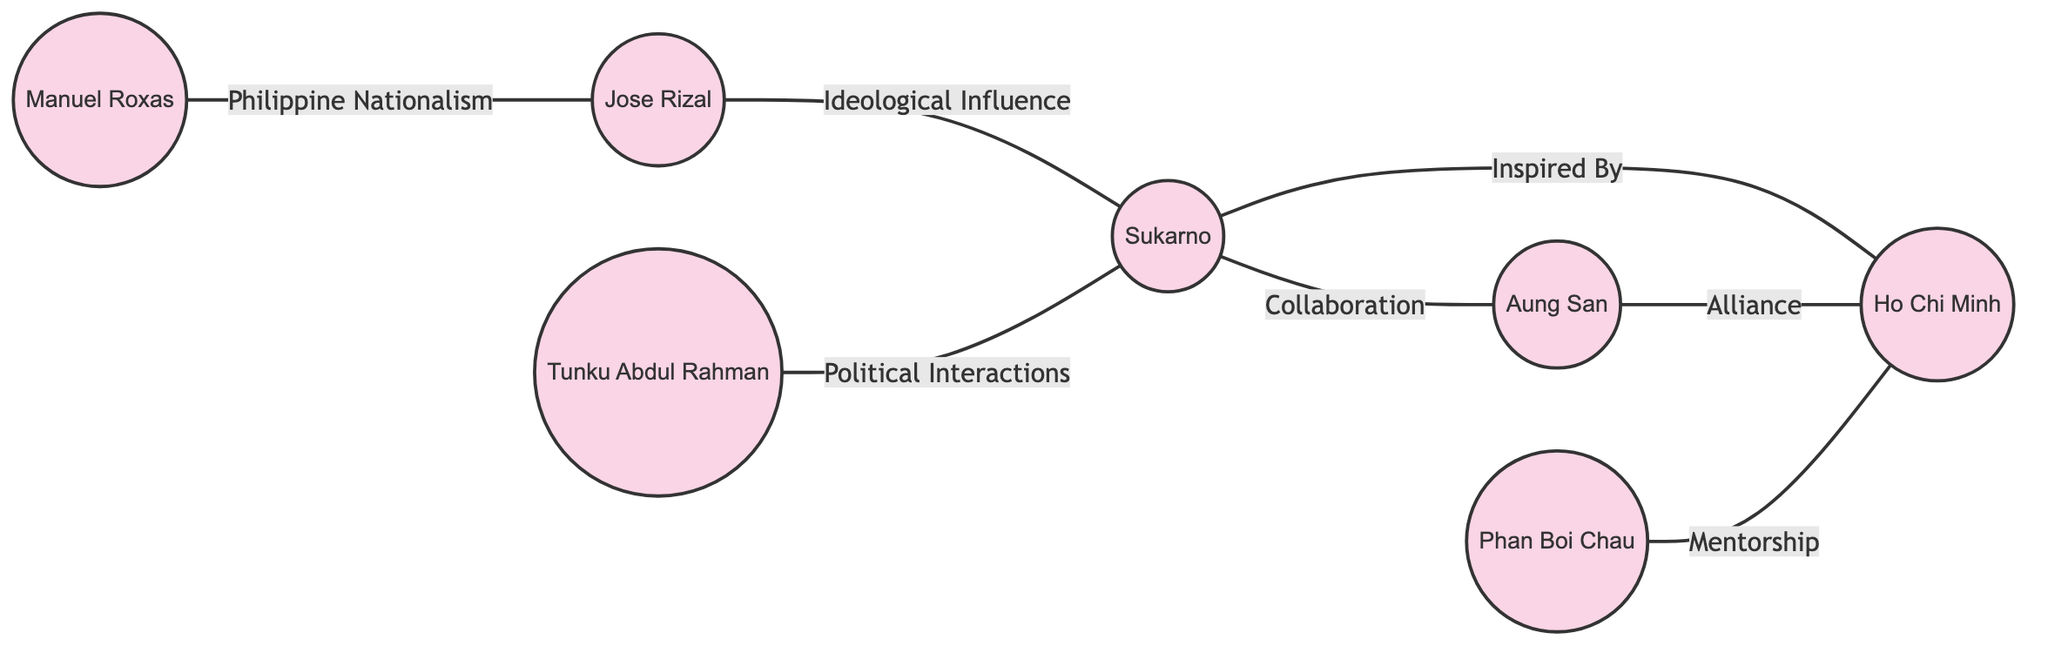What is the total number of nodes in the diagram? To find the total number of nodes, we count the individual key figures listed in the data section. They are Sukarno, Ho Chi Minh, Aung San, Jose Rizal, Tunku Abdul Rahman, Manuel Roxas, and Phan Boi Chau. There are 7 nodes in total.
Answer: 7 Who influenced Sukarno ideologically? The diagram shows a direct connection labeled 'Ideological Influence' between Jose Rizal and Sukarno. Therefore, the person who influenced Sukarno ideologically is Jose Rizal.
Answer: Jose Rizal Which key figure is both inspired by Sukarno and has a collaborative relationship with Aung San? By analyzing the connections, Sukarno is shown to be inspired by Ho Chi Minh and collaborates with Aung San. However, the question asks for a single figure related to both. The answer is thus Ho Chi Minh, as he has the 'Inspired By' relationship with Sukarno and an 'Alliance' with Aung San, making him central to both relationships.
Answer: Ho Chi Minh How many edges are in the graph? To determine the number of edges, we count the connections established between the nodes. The edges in the data are as follows: Inspired By (1), Collaboration (1), Alliance (1), Ideological Influence (1), Political Interactions (1), Philippine Nationalism (1), and Mentorship (1). Counting these gives us a total of 7 edges.
Answer: 7 Which two figures have a mentorship relationship? The diagram specifies that Phan Boi Chau has a mentorship relationship with Ho Chi Minh, as shown in the edge labeled 'Mentorship.' Therefore, the two figures with a mentorship relationship are Phan Boi Chau and Ho Chi Minh.
Answer: Phan Boi Chau, Ho Chi Minh What is the relationship between Aung San and Ho Chi Minh? According to the edges, Aung San and Ho Chi Minh share an 'Alliance' relationship, as denoted by the edge labeled 'Alliance' between them. Therefore, the relationship is an alliance.
Answer: Alliance Which figure can be characterized by political interactions with Sukarno? The diagram displays a clear connection labeled 'Political Interactions' between Tunku Abdul Rahman and Sukarno. Thus, Tunku Abdul Rahman can be characterized by his political interactions with Sukarno.
Answer: Tunku Abdul Rahman Who has a relationship based on Philippine nationalism? The edge labeled 'Philippine Nationalism' directly connects Manuel Roxas and Jose Rizal. Therefore, Manuel Roxas has a relationship based on Philippine nationalism, as indicated in the diagram.
Answer: Manuel Roxas 